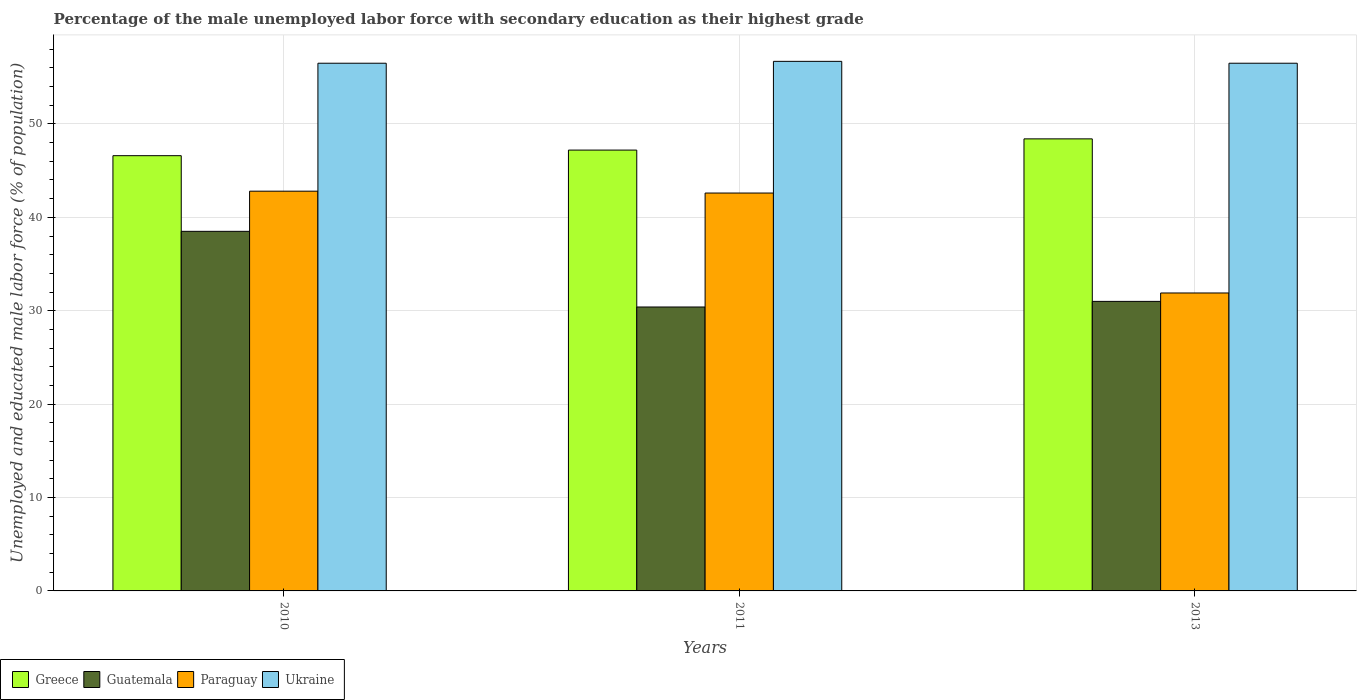Are the number of bars on each tick of the X-axis equal?
Give a very brief answer. Yes. How many bars are there on the 3rd tick from the left?
Your response must be concise. 4. What is the label of the 2nd group of bars from the left?
Your answer should be compact. 2011. What is the percentage of the unemployed male labor force with secondary education in Ukraine in 2013?
Ensure brevity in your answer.  56.5. Across all years, what is the maximum percentage of the unemployed male labor force with secondary education in Guatemala?
Provide a succinct answer. 38.5. Across all years, what is the minimum percentage of the unemployed male labor force with secondary education in Greece?
Provide a succinct answer. 46.6. What is the total percentage of the unemployed male labor force with secondary education in Paraguay in the graph?
Ensure brevity in your answer.  117.3. What is the difference between the percentage of the unemployed male labor force with secondary education in Greece in 2010 and that in 2011?
Ensure brevity in your answer.  -0.6. What is the difference between the percentage of the unemployed male labor force with secondary education in Guatemala in 2011 and the percentage of the unemployed male labor force with secondary education in Greece in 2013?
Offer a terse response. -18. What is the average percentage of the unemployed male labor force with secondary education in Greece per year?
Offer a terse response. 47.4. In the year 2010, what is the difference between the percentage of the unemployed male labor force with secondary education in Paraguay and percentage of the unemployed male labor force with secondary education in Greece?
Give a very brief answer. -3.8. In how many years, is the percentage of the unemployed male labor force with secondary education in Paraguay greater than 56 %?
Offer a very short reply. 0. What is the ratio of the percentage of the unemployed male labor force with secondary education in Greece in 2011 to that in 2013?
Your answer should be compact. 0.98. What is the difference between the highest and the second highest percentage of the unemployed male labor force with secondary education in Paraguay?
Offer a very short reply. 0.2. What is the difference between the highest and the lowest percentage of the unemployed male labor force with secondary education in Guatemala?
Make the answer very short. 8.1. What does the 4th bar from the left in 2010 represents?
Your answer should be compact. Ukraine. What does the 2nd bar from the right in 2013 represents?
Provide a short and direct response. Paraguay. How many bars are there?
Keep it short and to the point. 12. How many years are there in the graph?
Your answer should be compact. 3. What is the difference between two consecutive major ticks on the Y-axis?
Offer a very short reply. 10. Does the graph contain grids?
Provide a short and direct response. Yes. What is the title of the graph?
Provide a succinct answer. Percentage of the male unemployed labor force with secondary education as their highest grade. What is the label or title of the Y-axis?
Give a very brief answer. Unemployed and educated male labor force (% of population). What is the Unemployed and educated male labor force (% of population) of Greece in 2010?
Provide a short and direct response. 46.6. What is the Unemployed and educated male labor force (% of population) of Guatemala in 2010?
Your answer should be compact. 38.5. What is the Unemployed and educated male labor force (% of population) in Paraguay in 2010?
Offer a terse response. 42.8. What is the Unemployed and educated male labor force (% of population) of Ukraine in 2010?
Provide a succinct answer. 56.5. What is the Unemployed and educated male labor force (% of population) of Greece in 2011?
Provide a succinct answer. 47.2. What is the Unemployed and educated male labor force (% of population) of Guatemala in 2011?
Provide a succinct answer. 30.4. What is the Unemployed and educated male labor force (% of population) of Paraguay in 2011?
Your response must be concise. 42.6. What is the Unemployed and educated male labor force (% of population) of Ukraine in 2011?
Keep it short and to the point. 56.7. What is the Unemployed and educated male labor force (% of population) in Greece in 2013?
Offer a very short reply. 48.4. What is the Unemployed and educated male labor force (% of population) in Guatemala in 2013?
Offer a very short reply. 31. What is the Unemployed and educated male labor force (% of population) in Paraguay in 2013?
Offer a terse response. 31.9. What is the Unemployed and educated male labor force (% of population) in Ukraine in 2013?
Make the answer very short. 56.5. Across all years, what is the maximum Unemployed and educated male labor force (% of population) in Greece?
Keep it short and to the point. 48.4. Across all years, what is the maximum Unemployed and educated male labor force (% of population) in Guatemala?
Your answer should be compact. 38.5. Across all years, what is the maximum Unemployed and educated male labor force (% of population) in Paraguay?
Provide a succinct answer. 42.8. Across all years, what is the maximum Unemployed and educated male labor force (% of population) in Ukraine?
Provide a short and direct response. 56.7. Across all years, what is the minimum Unemployed and educated male labor force (% of population) of Greece?
Your answer should be very brief. 46.6. Across all years, what is the minimum Unemployed and educated male labor force (% of population) of Guatemala?
Your answer should be compact. 30.4. Across all years, what is the minimum Unemployed and educated male labor force (% of population) of Paraguay?
Provide a succinct answer. 31.9. Across all years, what is the minimum Unemployed and educated male labor force (% of population) in Ukraine?
Provide a short and direct response. 56.5. What is the total Unemployed and educated male labor force (% of population) in Greece in the graph?
Your answer should be compact. 142.2. What is the total Unemployed and educated male labor force (% of population) of Guatemala in the graph?
Make the answer very short. 99.9. What is the total Unemployed and educated male labor force (% of population) of Paraguay in the graph?
Keep it short and to the point. 117.3. What is the total Unemployed and educated male labor force (% of population) in Ukraine in the graph?
Offer a terse response. 169.7. What is the difference between the Unemployed and educated male labor force (% of population) of Greece in 2010 and that in 2011?
Ensure brevity in your answer.  -0.6. What is the difference between the Unemployed and educated male labor force (% of population) of Guatemala in 2010 and that in 2011?
Make the answer very short. 8.1. What is the difference between the Unemployed and educated male labor force (% of population) in Ukraine in 2010 and that in 2011?
Offer a very short reply. -0.2. What is the difference between the Unemployed and educated male labor force (% of population) in Guatemala in 2010 and that in 2013?
Provide a succinct answer. 7.5. What is the difference between the Unemployed and educated male labor force (% of population) of Ukraine in 2011 and that in 2013?
Keep it short and to the point. 0.2. What is the difference between the Unemployed and educated male labor force (% of population) in Greece in 2010 and the Unemployed and educated male labor force (% of population) in Guatemala in 2011?
Provide a succinct answer. 16.2. What is the difference between the Unemployed and educated male labor force (% of population) of Greece in 2010 and the Unemployed and educated male labor force (% of population) of Paraguay in 2011?
Your answer should be compact. 4. What is the difference between the Unemployed and educated male labor force (% of population) in Guatemala in 2010 and the Unemployed and educated male labor force (% of population) in Paraguay in 2011?
Provide a short and direct response. -4.1. What is the difference between the Unemployed and educated male labor force (% of population) of Guatemala in 2010 and the Unemployed and educated male labor force (% of population) of Ukraine in 2011?
Ensure brevity in your answer.  -18.2. What is the difference between the Unemployed and educated male labor force (% of population) in Guatemala in 2010 and the Unemployed and educated male labor force (% of population) in Paraguay in 2013?
Make the answer very short. 6.6. What is the difference between the Unemployed and educated male labor force (% of population) of Guatemala in 2010 and the Unemployed and educated male labor force (% of population) of Ukraine in 2013?
Your response must be concise. -18. What is the difference between the Unemployed and educated male labor force (% of population) of Paraguay in 2010 and the Unemployed and educated male labor force (% of population) of Ukraine in 2013?
Ensure brevity in your answer.  -13.7. What is the difference between the Unemployed and educated male labor force (% of population) in Greece in 2011 and the Unemployed and educated male labor force (% of population) in Guatemala in 2013?
Make the answer very short. 16.2. What is the difference between the Unemployed and educated male labor force (% of population) in Greece in 2011 and the Unemployed and educated male labor force (% of population) in Paraguay in 2013?
Give a very brief answer. 15.3. What is the difference between the Unemployed and educated male labor force (% of population) of Guatemala in 2011 and the Unemployed and educated male labor force (% of population) of Paraguay in 2013?
Make the answer very short. -1.5. What is the difference between the Unemployed and educated male labor force (% of population) in Guatemala in 2011 and the Unemployed and educated male labor force (% of population) in Ukraine in 2013?
Make the answer very short. -26.1. What is the average Unemployed and educated male labor force (% of population) in Greece per year?
Keep it short and to the point. 47.4. What is the average Unemployed and educated male labor force (% of population) in Guatemala per year?
Your answer should be compact. 33.3. What is the average Unemployed and educated male labor force (% of population) of Paraguay per year?
Keep it short and to the point. 39.1. What is the average Unemployed and educated male labor force (% of population) in Ukraine per year?
Your answer should be compact. 56.57. In the year 2010, what is the difference between the Unemployed and educated male labor force (% of population) in Greece and Unemployed and educated male labor force (% of population) in Guatemala?
Keep it short and to the point. 8.1. In the year 2010, what is the difference between the Unemployed and educated male labor force (% of population) in Greece and Unemployed and educated male labor force (% of population) in Paraguay?
Ensure brevity in your answer.  3.8. In the year 2010, what is the difference between the Unemployed and educated male labor force (% of population) of Greece and Unemployed and educated male labor force (% of population) of Ukraine?
Provide a short and direct response. -9.9. In the year 2010, what is the difference between the Unemployed and educated male labor force (% of population) in Guatemala and Unemployed and educated male labor force (% of population) in Ukraine?
Give a very brief answer. -18. In the year 2010, what is the difference between the Unemployed and educated male labor force (% of population) in Paraguay and Unemployed and educated male labor force (% of population) in Ukraine?
Your answer should be very brief. -13.7. In the year 2011, what is the difference between the Unemployed and educated male labor force (% of population) in Greece and Unemployed and educated male labor force (% of population) in Guatemala?
Ensure brevity in your answer.  16.8. In the year 2011, what is the difference between the Unemployed and educated male labor force (% of population) of Greece and Unemployed and educated male labor force (% of population) of Paraguay?
Ensure brevity in your answer.  4.6. In the year 2011, what is the difference between the Unemployed and educated male labor force (% of population) of Guatemala and Unemployed and educated male labor force (% of population) of Paraguay?
Give a very brief answer. -12.2. In the year 2011, what is the difference between the Unemployed and educated male labor force (% of population) of Guatemala and Unemployed and educated male labor force (% of population) of Ukraine?
Offer a very short reply. -26.3. In the year 2011, what is the difference between the Unemployed and educated male labor force (% of population) of Paraguay and Unemployed and educated male labor force (% of population) of Ukraine?
Provide a succinct answer. -14.1. In the year 2013, what is the difference between the Unemployed and educated male labor force (% of population) in Greece and Unemployed and educated male labor force (% of population) in Guatemala?
Give a very brief answer. 17.4. In the year 2013, what is the difference between the Unemployed and educated male labor force (% of population) of Greece and Unemployed and educated male labor force (% of population) of Ukraine?
Provide a short and direct response. -8.1. In the year 2013, what is the difference between the Unemployed and educated male labor force (% of population) of Guatemala and Unemployed and educated male labor force (% of population) of Ukraine?
Provide a succinct answer. -25.5. In the year 2013, what is the difference between the Unemployed and educated male labor force (% of population) in Paraguay and Unemployed and educated male labor force (% of population) in Ukraine?
Make the answer very short. -24.6. What is the ratio of the Unemployed and educated male labor force (% of population) of Greece in 2010 to that in 2011?
Ensure brevity in your answer.  0.99. What is the ratio of the Unemployed and educated male labor force (% of population) of Guatemala in 2010 to that in 2011?
Provide a succinct answer. 1.27. What is the ratio of the Unemployed and educated male labor force (% of population) of Paraguay in 2010 to that in 2011?
Provide a short and direct response. 1. What is the ratio of the Unemployed and educated male labor force (% of population) in Greece in 2010 to that in 2013?
Your answer should be very brief. 0.96. What is the ratio of the Unemployed and educated male labor force (% of population) of Guatemala in 2010 to that in 2013?
Keep it short and to the point. 1.24. What is the ratio of the Unemployed and educated male labor force (% of population) of Paraguay in 2010 to that in 2013?
Offer a very short reply. 1.34. What is the ratio of the Unemployed and educated male labor force (% of population) in Ukraine in 2010 to that in 2013?
Make the answer very short. 1. What is the ratio of the Unemployed and educated male labor force (% of population) of Greece in 2011 to that in 2013?
Give a very brief answer. 0.98. What is the ratio of the Unemployed and educated male labor force (% of population) in Guatemala in 2011 to that in 2013?
Offer a very short reply. 0.98. What is the ratio of the Unemployed and educated male labor force (% of population) of Paraguay in 2011 to that in 2013?
Give a very brief answer. 1.34. What is the difference between the highest and the second highest Unemployed and educated male labor force (% of population) in Greece?
Your answer should be very brief. 1.2. What is the difference between the highest and the second highest Unemployed and educated male labor force (% of population) of Guatemala?
Ensure brevity in your answer.  7.5. What is the difference between the highest and the second highest Unemployed and educated male labor force (% of population) of Paraguay?
Give a very brief answer. 0.2. 